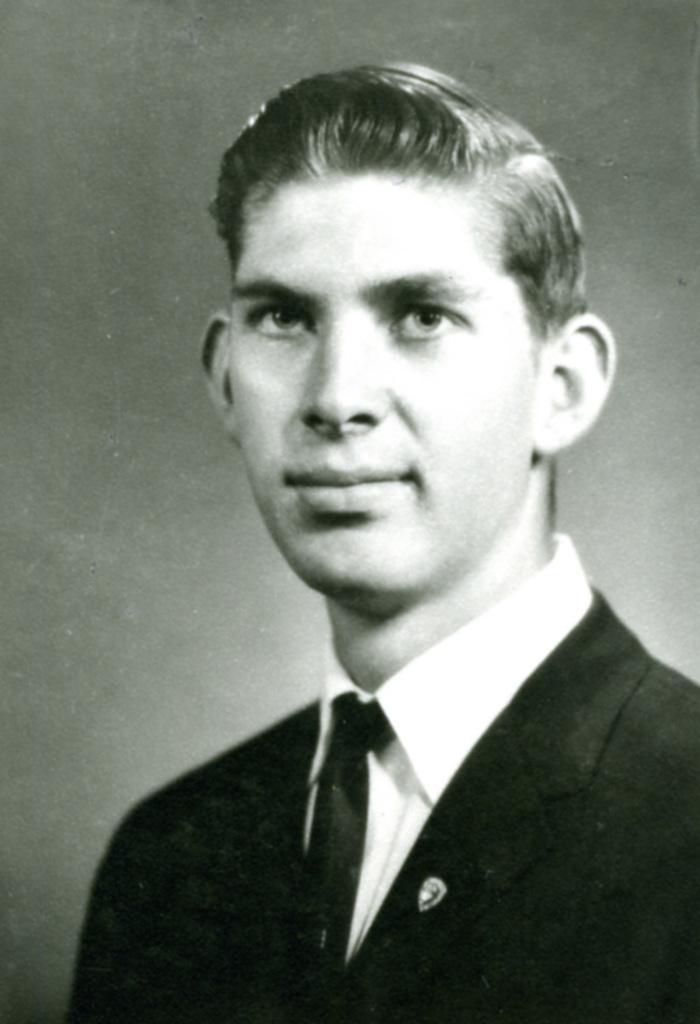Please provide a concise description of this image. In this picture we can observe a man wearing a coat and a tie. This is a black and white image. This man is smiling. 